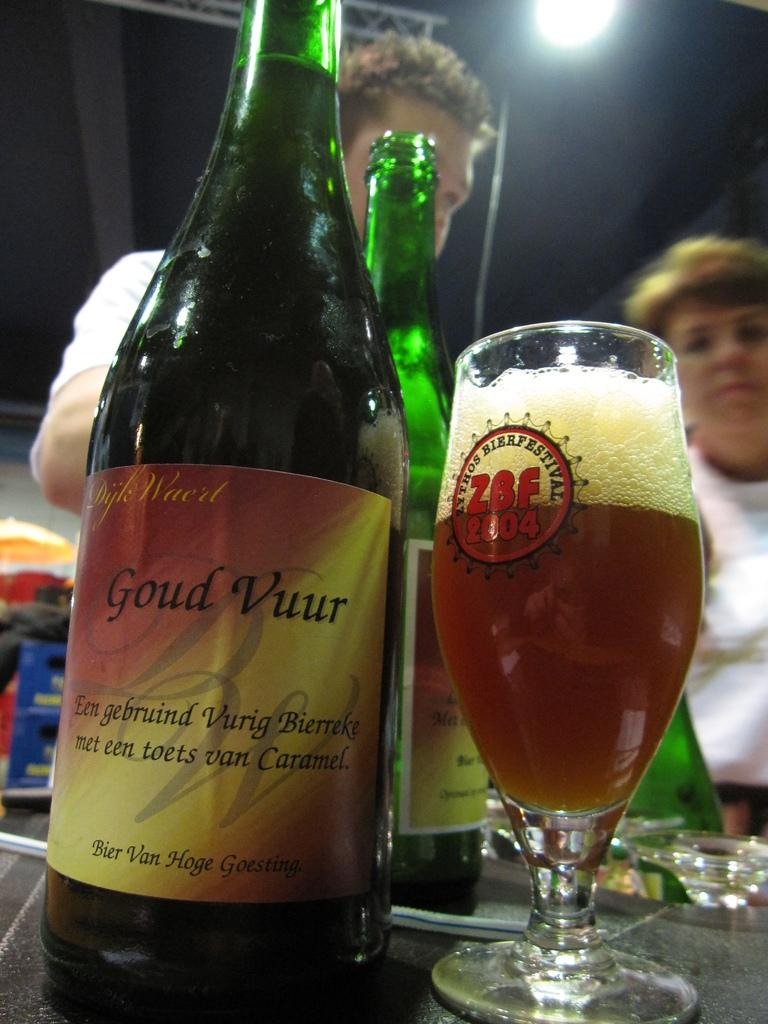<image>
Describe the image concisely. A bottle of Goud Vuur is next to a full glass. 